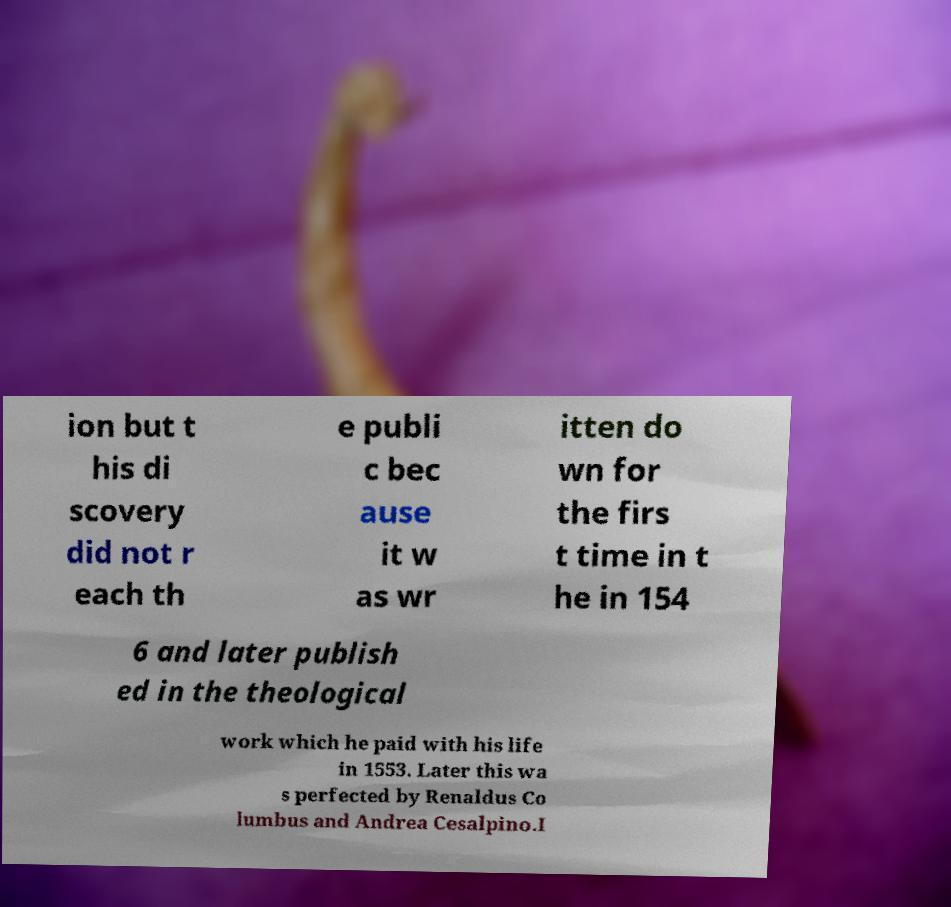Can you accurately transcribe the text from the provided image for me? ion but t his di scovery did not r each th e publi c bec ause it w as wr itten do wn for the firs t time in t he in 154 6 and later publish ed in the theological work which he paid with his life in 1553. Later this wa s perfected by Renaldus Co lumbus and Andrea Cesalpino.I 